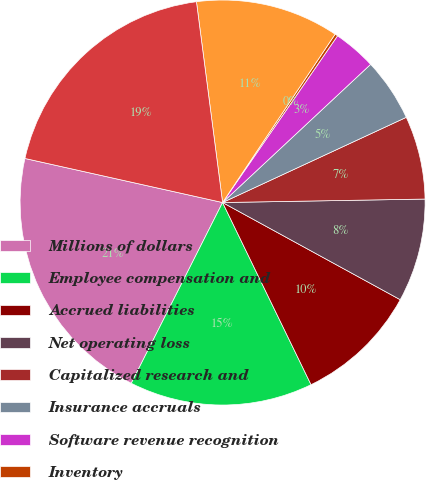Convert chart to OTSL. <chart><loc_0><loc_0><loc_500><loc_500><pie_chart><fcel>Millions of dollars<fcel>Employee compensation and<fcel>Accrued liabilities<fcel>Net operating loss<fcel>Capitalized research and<fcel>Insurance accruals<fcel>Software revenue recognition<fcel>Inventory<fcel>Other<fcel>Total gross deferred tax<nl><fcel>21.05%<fcel>14.64%<fcel>9.84%<fcel>8.24%<fcel>6.64%<fcel>5.04%<fcel>3.44%<fcel>0.23%<fcel>11.44%<fcel>19.45%<nl></chart> 